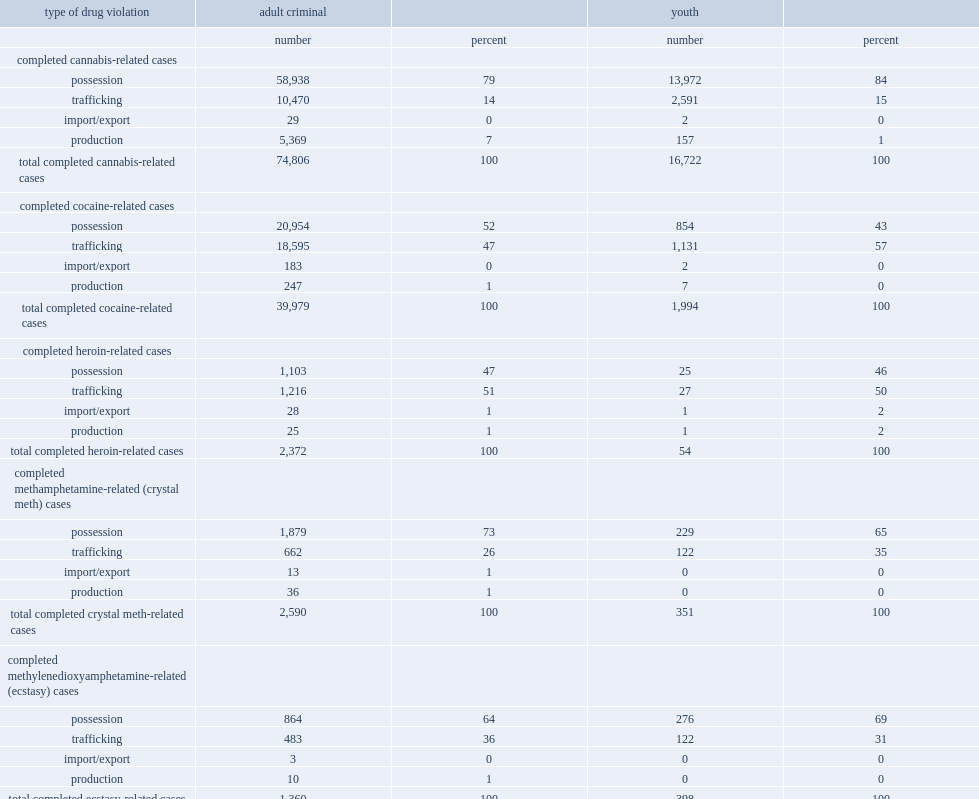What is the percentage of completed drug-related cases in adult criminal courts involved charges related to possession from 2008/2009 to 2011/2012? 69.0. For adults, there was a difference in the proportion of possession cases by type of drug, what is the percentage of completed cases related to cannabis involved possession from 2008/2009 to 2011/2012? 79.0. What is the percentage of completed drug-related youth court cases involved possession from 2008/2009 to 2011/2012? 77.0. What is the percentage ofcannabis-related youth court cases involved possession from 2008/2009 to 2011/2012? 84.0. What is the percentage of completed drug-related cases in adult criminal courts involved trafficking from 2008/2009 to 2011/2012? 27.0. What is the percentage related to production of completed drug-related cases in adult criminal courts from 2008/2009 to 2011/2012? 4.0. What is the percentage related to import or export charges of completed drug-related cases in adult criminal courts from 2008/2009 to 2011/2012? 0.0. 